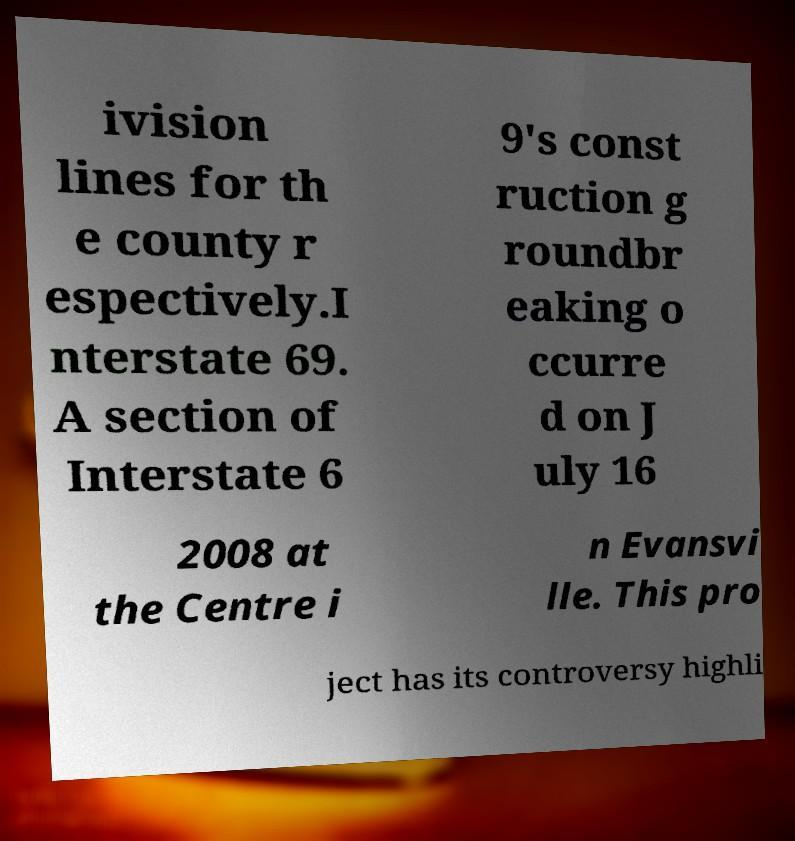For documentation purposes, I need the text within this image transcribed. Could you provide that? ivision lines for th e county r espectively.I nterstate 69. A section of Interstate 6 9's const ruction g roundbr eaking o ccurre d on J uly 16 2008 at the Centre i n Evansvi lle. This pro ject has its controversy highli 